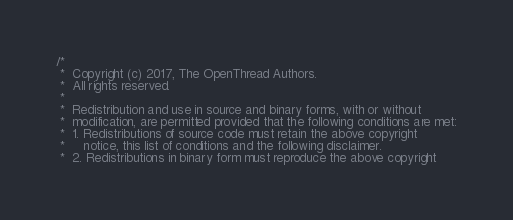Convert code to text. <code><loc_0><loc_0><loc_500><loc_500><_C++_>/*
 *  Copyright (c) 2017, The OpenThread Authors.
 *  All rights reserved.
 *
 *  Redistribution and use in source and binary forms, with or without
 *  modification, are permitted provided that the following conditions are met:
 *  1. Redistributions of source code must retain the above copyright
 *     notice, this list of conditions and the following disclaimer.
 *  2. Redistributions in binary form must reproduce the above copyright</code> 